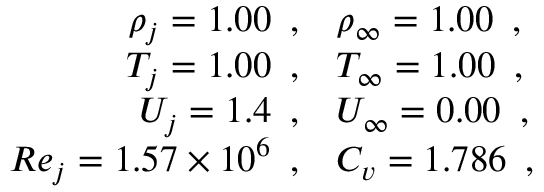Convert formula to latex. <formula><loc_0><loc_0><loc_500><loc_500>\begin{array} { r l } { \rho _ { j } = 1 . 0 0 \, , } & { \rho _ { \infty } = 1 . 0 0 \, , } \\ { T _ { j } = 1 . 0 0 \, , } & { T _ { \infty } = 1 . 0 0 \, , } \\ { U _ { j } = 1 . 4 \, , } & { U _ { \infty } = 0 . 0 0 \, , } \\ { R e _ { j } = 1 . 5 7 \times 1 0 ^ { 6 } \, , } & { C _ { v } = 1 . 7 8 6 \, , } \end{array}</formula> 